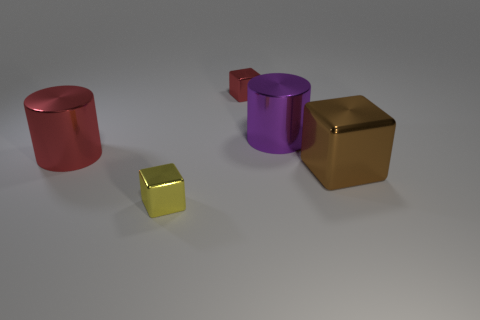Add 1 tiny yellow metal cubes. How many objects exist? 6 Subtract all blocks. How many objects are left? 2 Subtract 0 gray spheres. How many objects are left? 5 Subtract all big gray balls. Subtract all large brown metal blocks. How many objects are left? 4 Add 3 small metal blocks. How many small metal blocks are left? 5 Add 4 purple things. How many purple things exist? 5 